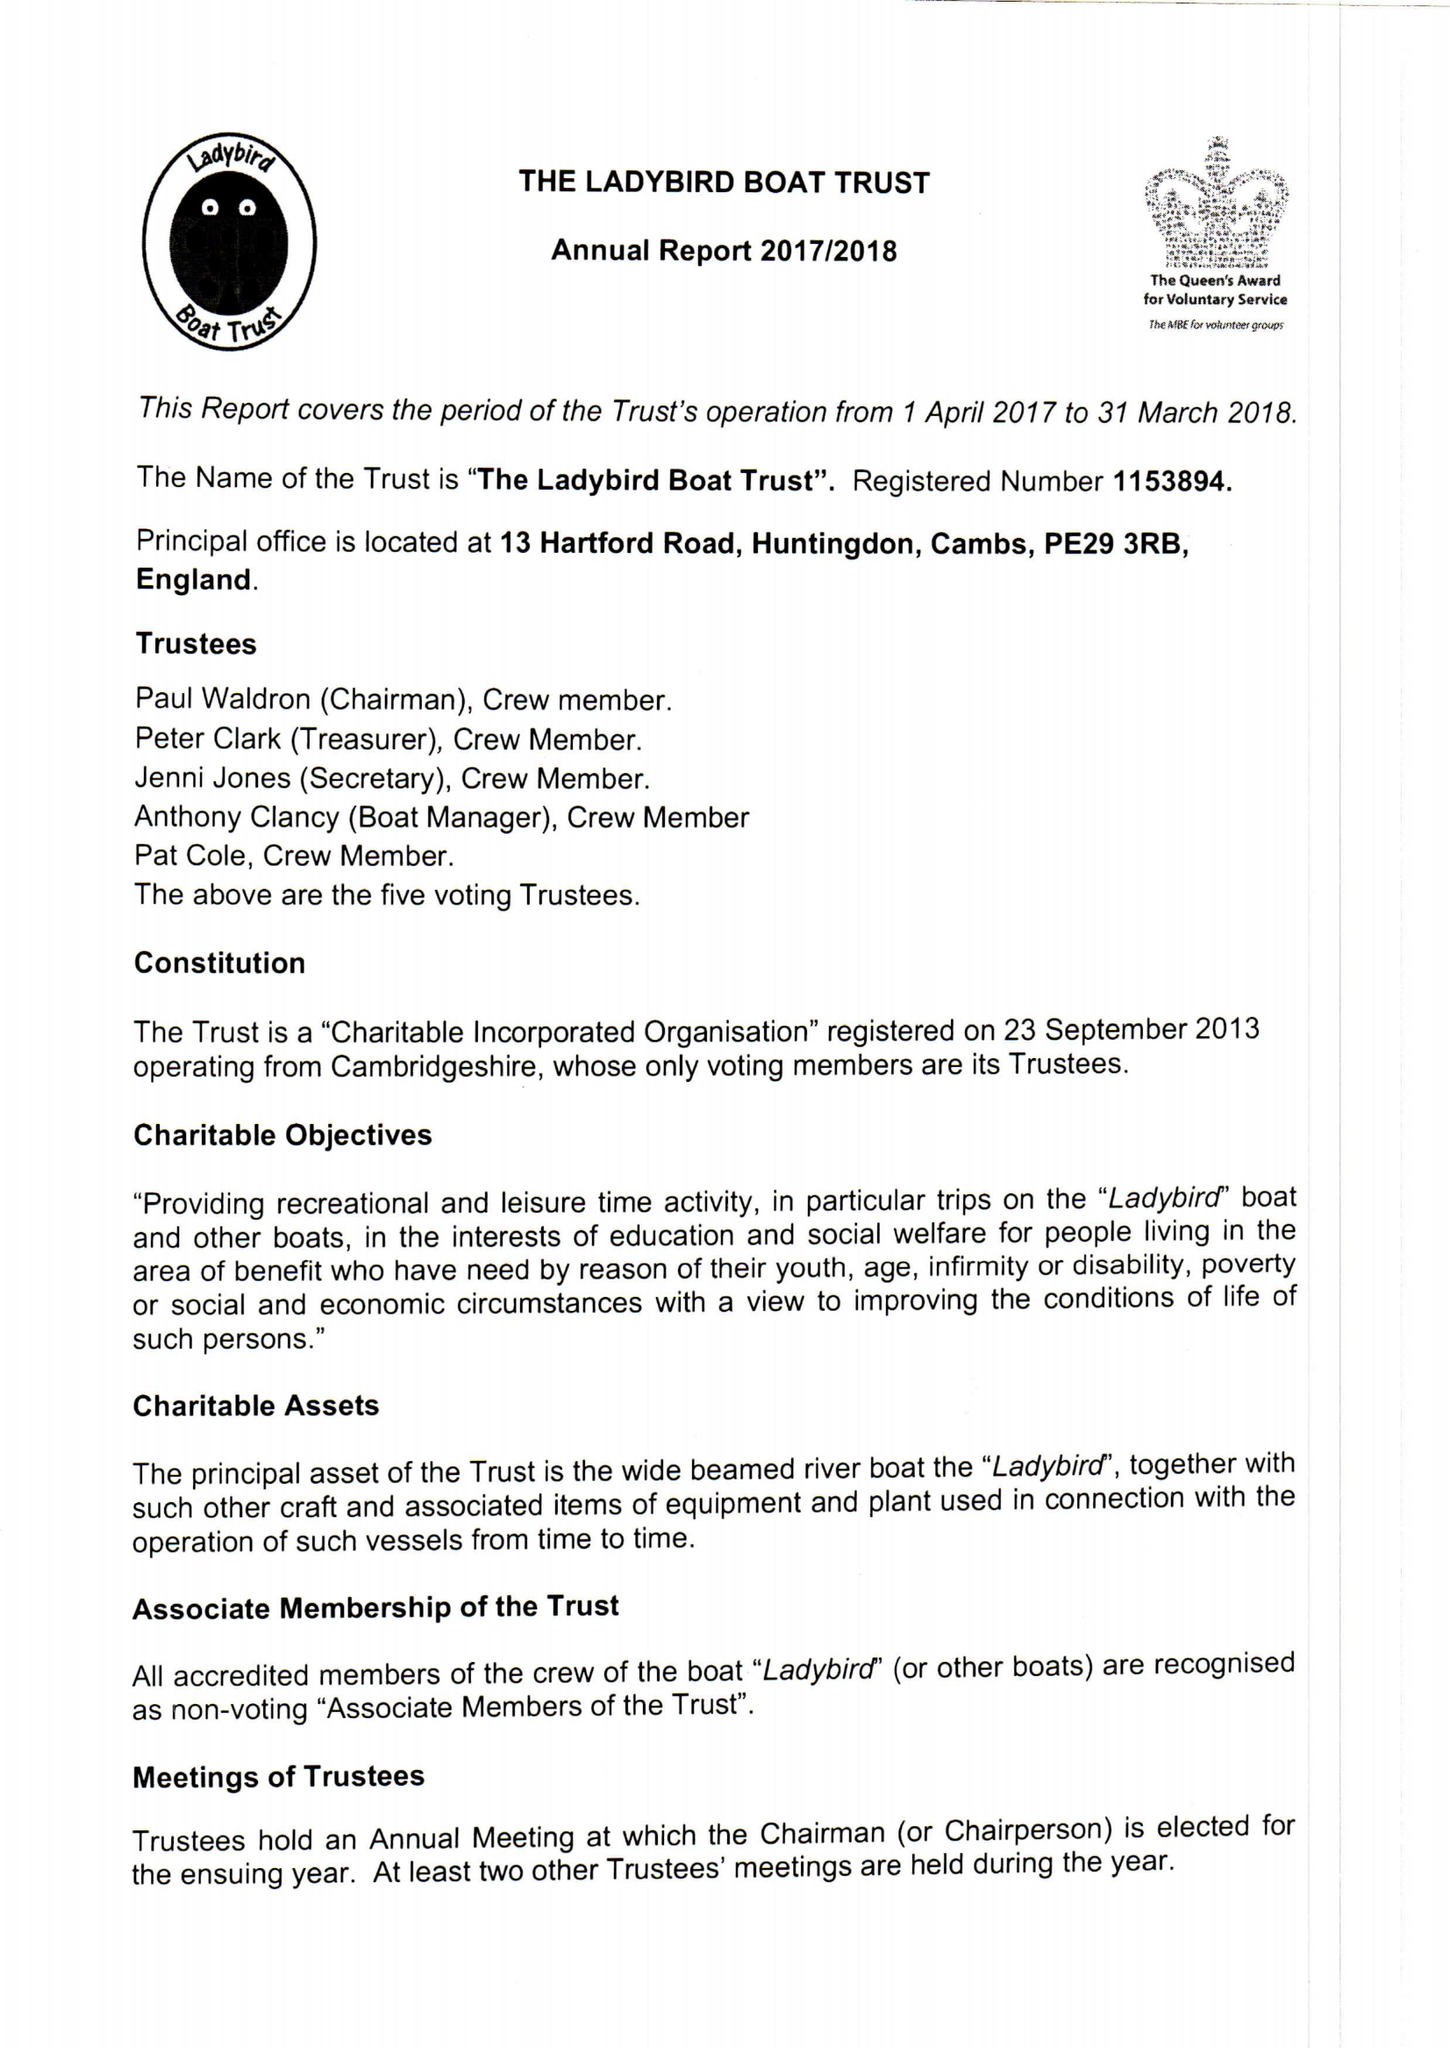What is the value for the address__street_line?
Answer the question using a single word or phrase. 13 HARTFORD ROAD 